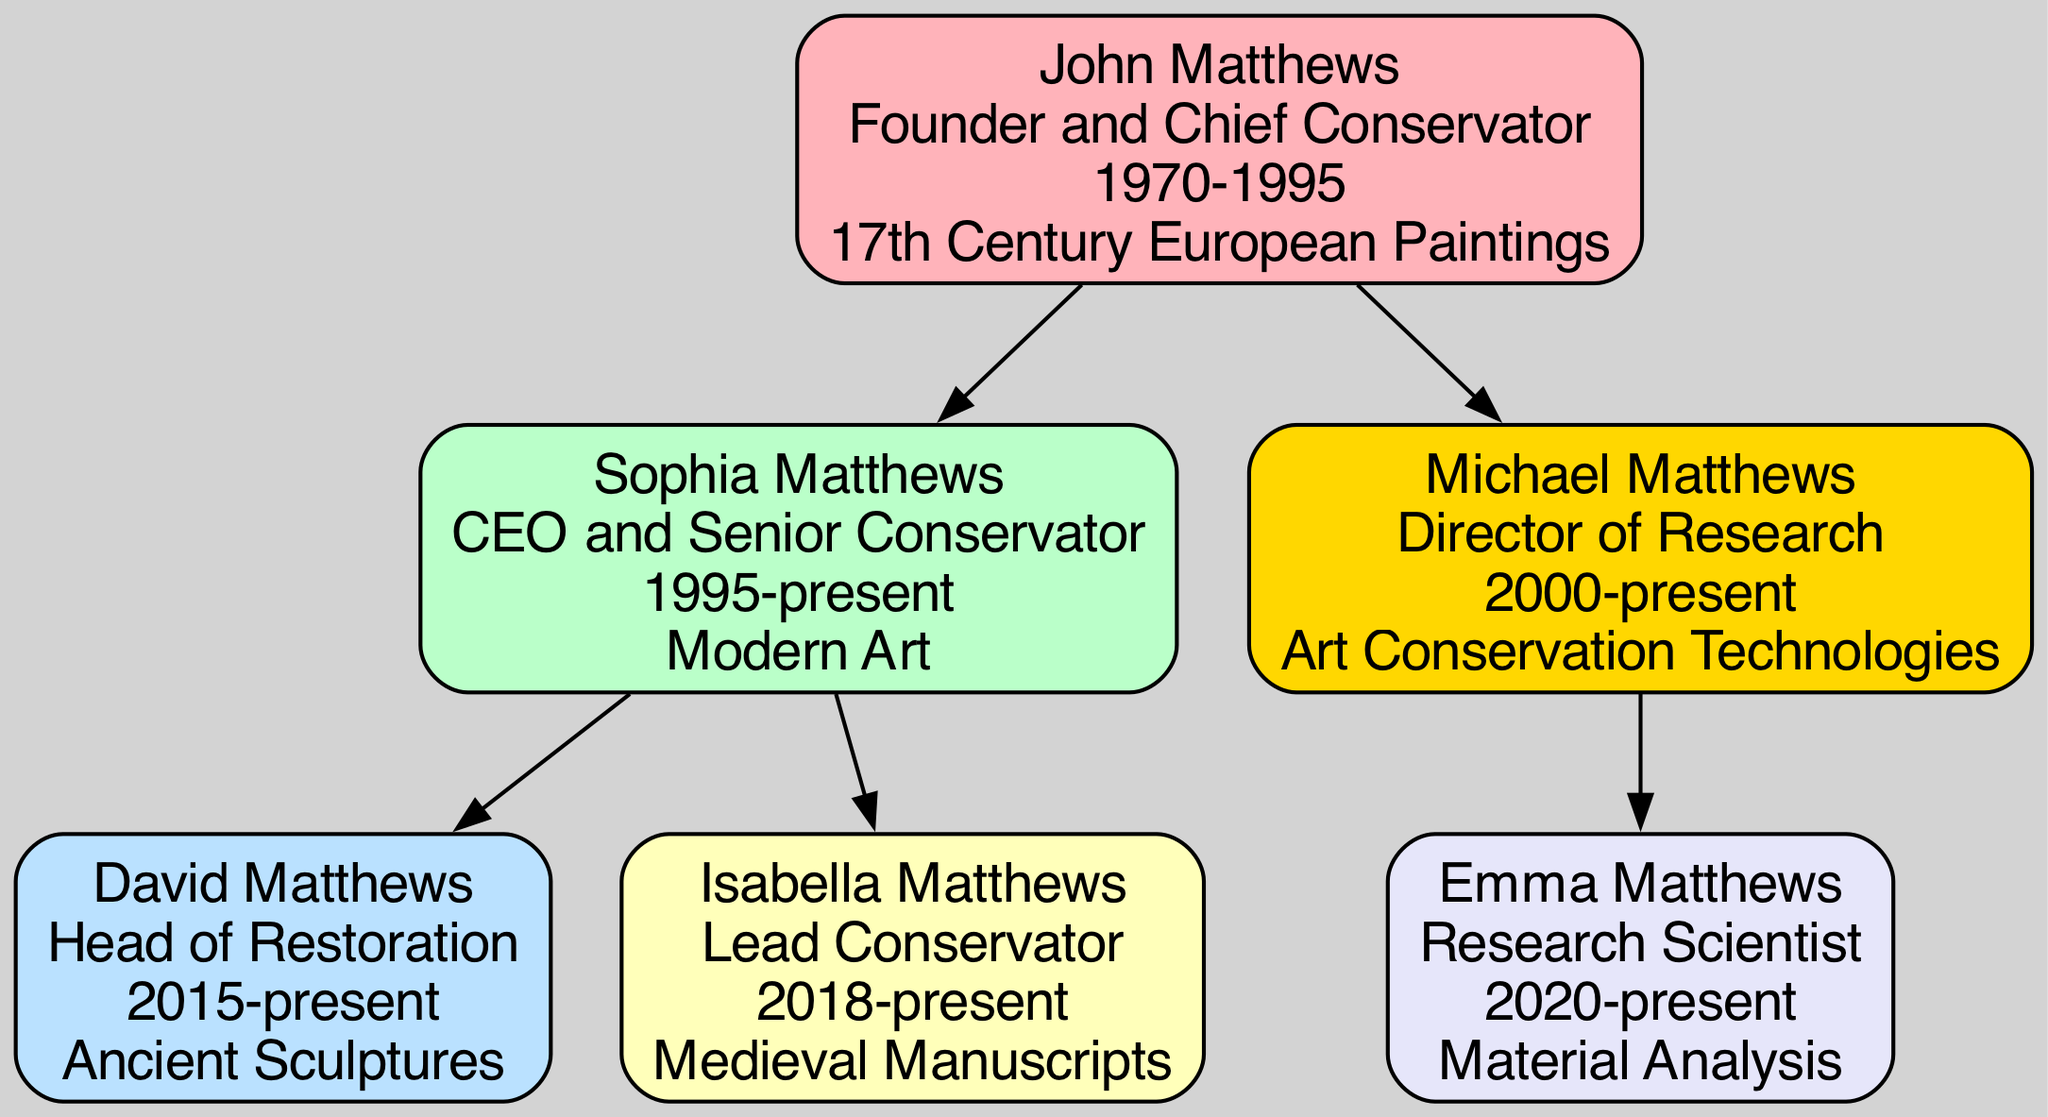What is the title of John Matthews? According to the diagram, John Matthews is identified with the title of "Founder and Chief Conservator." This information can be found directly under his name in the node representing him.
Answer: Founder and Chief Conservator Who specializes in Modern Art? From the diagram, Sophia Matthews is specified as the person who specializes in Modern Art. This can be checked in her node where her specialization is listed.
Answer: Sophia Matthews How many children does Michael Matthews have? Looking at the diagram, it can be observed that Michael Matthews has one child, Emma Matthews. This is evident from the structure, which shows one child node under Michael Matthews.
Answer: 1 Which role does Isabella Matthews hold? The diagram clearly indicates that Isabella Matthews holds the role of "Lead Conservator." This information is directly available in her corresponding node.
Answer: Lead Conservator What is the relationship between John Matthews and Sophia Matthews? The relationship between John Matthews and Sophia Matthews can be described as parent to child. This relationship is visualized by the downward connection from John Matthews' node to Sophia Matthews' node, indicating he is her father.
Answer: Parent to child Which specialization is unique to David Matthews? Examining the diagram reveals that David Matthews specializes in "Ancient Sculptures." This specialization is specifically mentioned in his node, distinguishing it from the other family members’ specializations.
Answer: Ancient Sculptures What year did Sophia Matthews start her role? According to the diagram, Sophia Matthews began her role in the year 1995, which is stated right under her name in the node depicting her details.
Answer: 1995 How many generations are listed in the family tree? The diagram illustrates three generations: John Matthews is the first generation, Sophia and Michael Matthews are the second generation, and David, Isabella, and Emma Matthews are the third. This count can be established by identifying distinct parent-child relationships at each level.
Answer: 3 What is the title of the youngest member in the tree? The youngest member in the family tree, according to the diagram, is Emma Matthews, who is described as a "Research Scientist." This title is mentioned directly in her node.
Answer: Research Scientist 